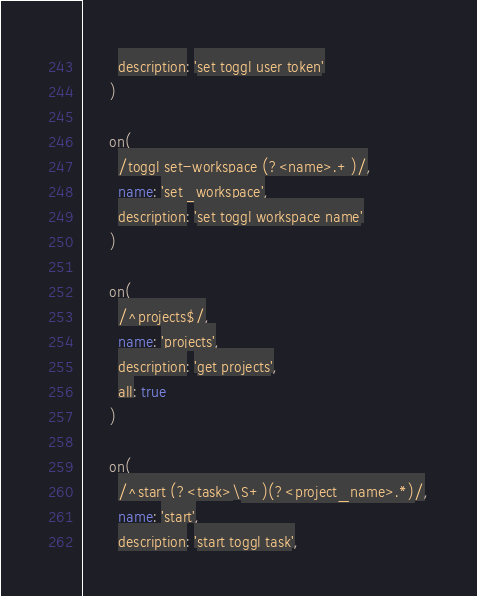<code> <loc_0><loc_0><loc_500><loc_500><_Ruby_>        description: 'set toggl user token'
      )

      on(
        /toggl set-workspace (?<name>.+)/,
        name: 'set_workspace',
        description: 'set toggl workspace name'
      )

      on(
        /^projects$/,
        name: 'projects',
        description: 'get projects',
        all: true
      )

      on(
        /^start (?<task>\S+)(?<project_name>.*)/,
        name: 'start',
        description: 'start toggl task',</code> 